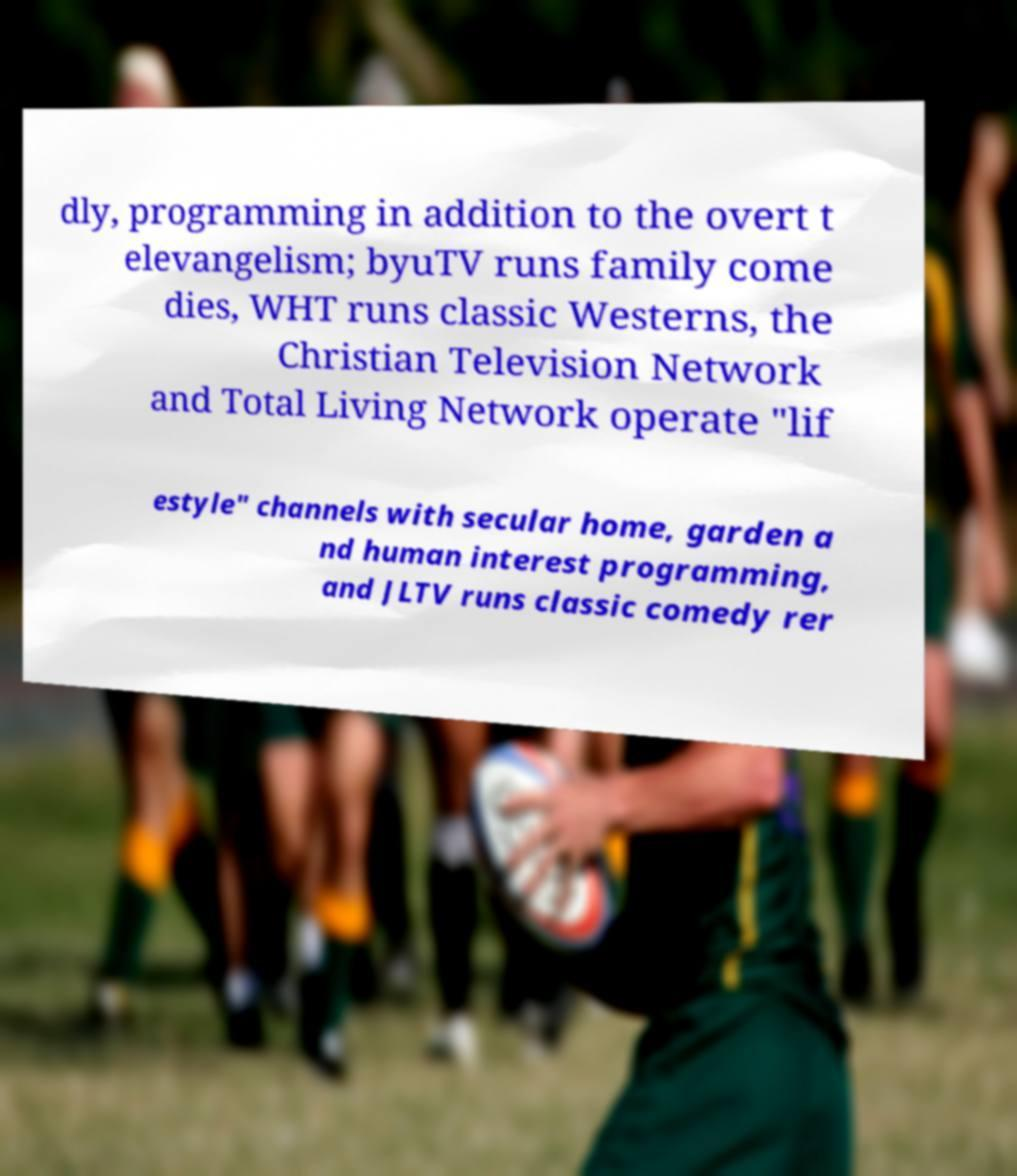I need the written content from this picture converted into text. Can you do that? dly, programming in addition to the overt t elevangelism; byuTV runs family come dies, WHT runs classic Westerns, the Christian Television Network and Total Living Network operate "lif estyle" channels with secular home, garden a nd human interest programming, and JLTV runs classic comedy rer 